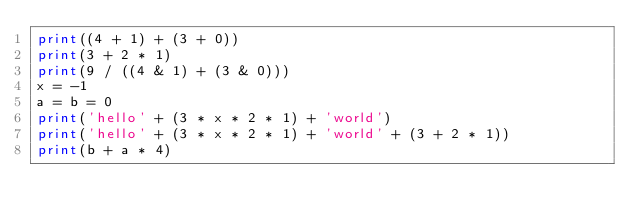Convert code to text. <code><loc_0><loc_0><loc_500><loc_500><_Python_>print((4 + 1) + (3 + 0))
print(3 + 2 * 1)
print(9 / ((4 & 1) + (3 & 0)))
x = -1
a = b = 0
print('hello' + (3 * x * 2 * 1) + 'world')
print('hello' + (3 * x * 2 * 1) + 'world' + (3 + 2 * 1))
print(b + a * 4)
</code> 